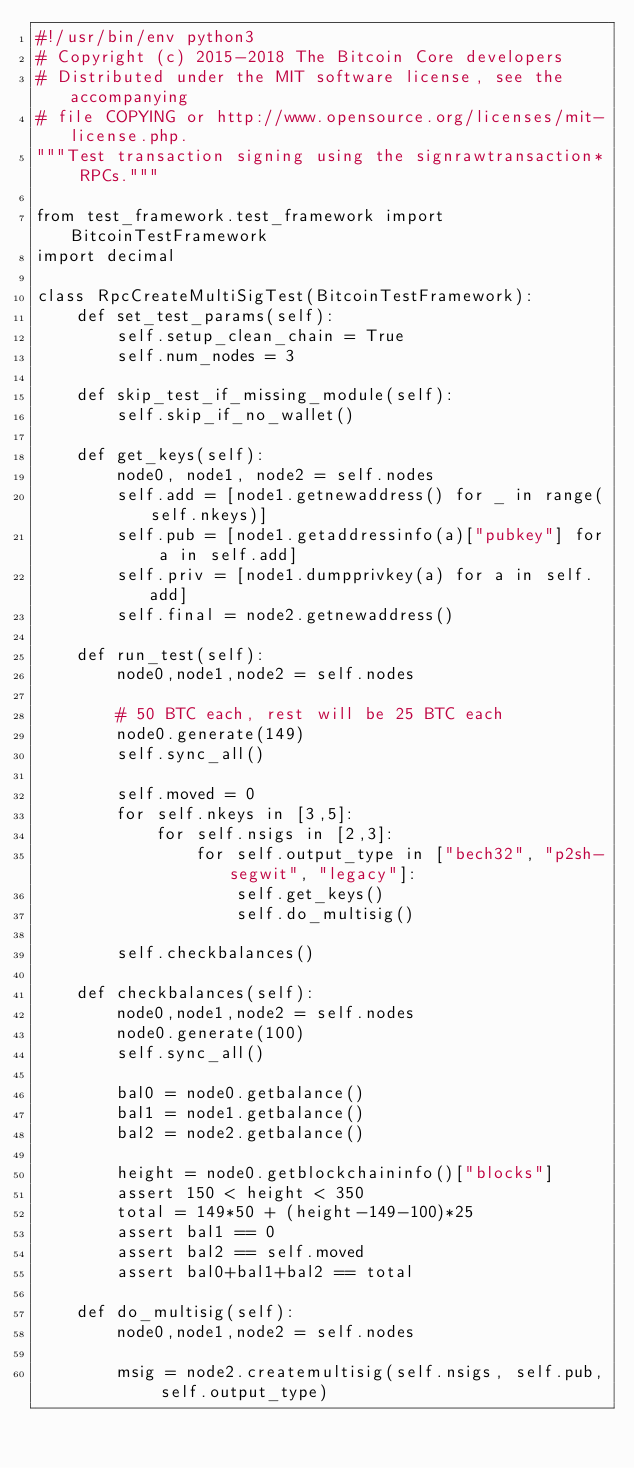<code> <loc_0><loc_0><loc_500><loc_500><_Python_>#!/usr/bin/env python3
# Copyright (c) 2015-2018 The Bitcoin Core developers
# Distributed under the MIT software license, see the accompanying
# file COPYING or http://www.opensource.org/licenses/mit-license.php.
"""Test transaction signing using the signrawtransaction* RPCs."""

from test_framework.test_framework import BitcoinTestFramework
import decimal

class RpcCreateMultiSigTest(BitcoinTestFramework):
    def set_test_params(self):
        self.setup_clean_chain = True
        self.num_nodes = 3

    def skip_test_if_missing_module(self):
        self.skip_if_no_wallet()

    def get_keys(self):
        node0, node1, node2 = self.nodes
        self.add = [node1.getnewaddress() for _ in range(self.nkeys)]
        self.pub = [node1.getaddressinfo(a)["pubkey"] for a in self.add]
        self.priv = [node1.dumpprivkey(a) for a in self.add]
        self.final = node2.getnewaddress()

    def run_test(self):
        node0,node1,node2 = self.nodes

        # 50 BTC each, rest will be 25 BTC each
        node0.generate(149)
        self.sync_all()

        self.moved = 0
        for self.nkeys in [3,5]:
            for self.nsigs in [2,3]:
                for self.output_type in ["bech32", "p2sh-segwit", "legacy"]:
                    self.get_keys()
                    self.do_multisig()

        self.checkbalances()

    def checkbalances(self):
        node0,node1,node2 = self.nodes
        node0.generate(100)
        self.sync_all()

        bal0 = node0.getbalance()
        bal1 = node1.getbalance()
        bal2 = node2.getbalance()

        height = node0.getblockchaininfo()["blocks"]
        assert 150 < height < 350
        total = 149*50 + (height-149-100)*25
        assert bal1 == 0
        assert bal2 == self.moved
        assert bal0+bal1+bal2 == total

    def do_multisig(self):
        node0,node1,node2 = self.nodes

        msig = node2.createmultisig(self.nsigs, self.pub, self.output_type)</code> 